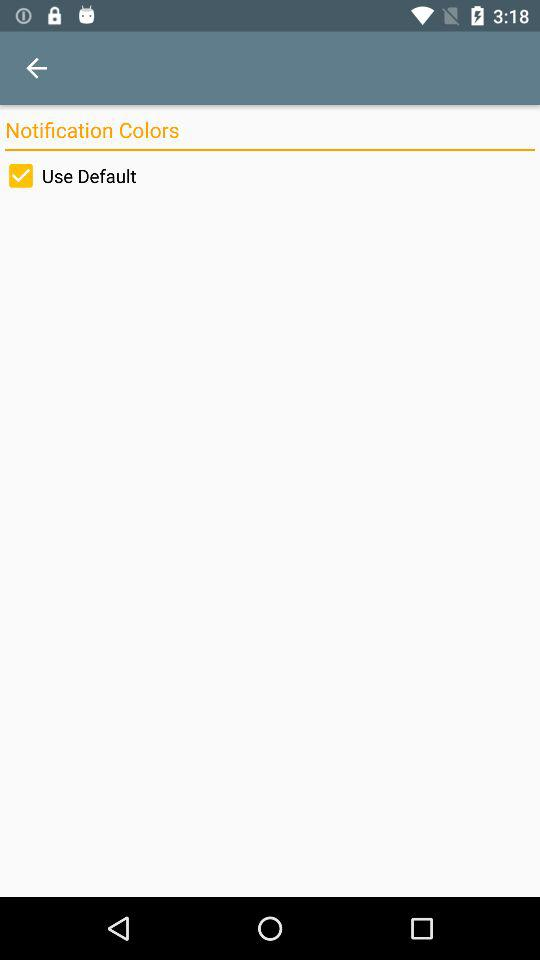Is "Use Default" checked or unchecked?
Answer the question using a single word or phrase. It is checked. 